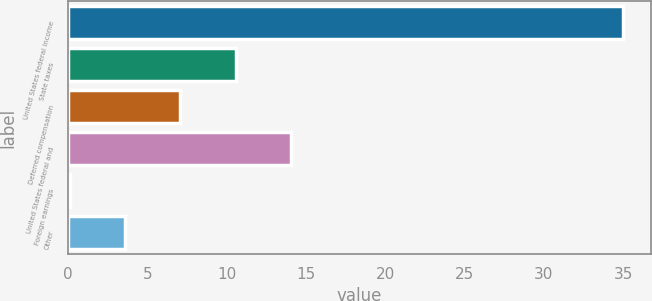Convert chart to OTSL. <chart><loc_0><loc_0><loc_500><loc_500><bar_chart><fcel>United States federal income<fcel>State taxes<fcel>Deferred compensation<fcel>United States federal and<fcel>Foreign earnings<fcel>Other<nl><fcel>35<fcel>10.57<fcel>7.08<fcel>14.06<fcel>0.1<fcel>3.59<nl></chart> 